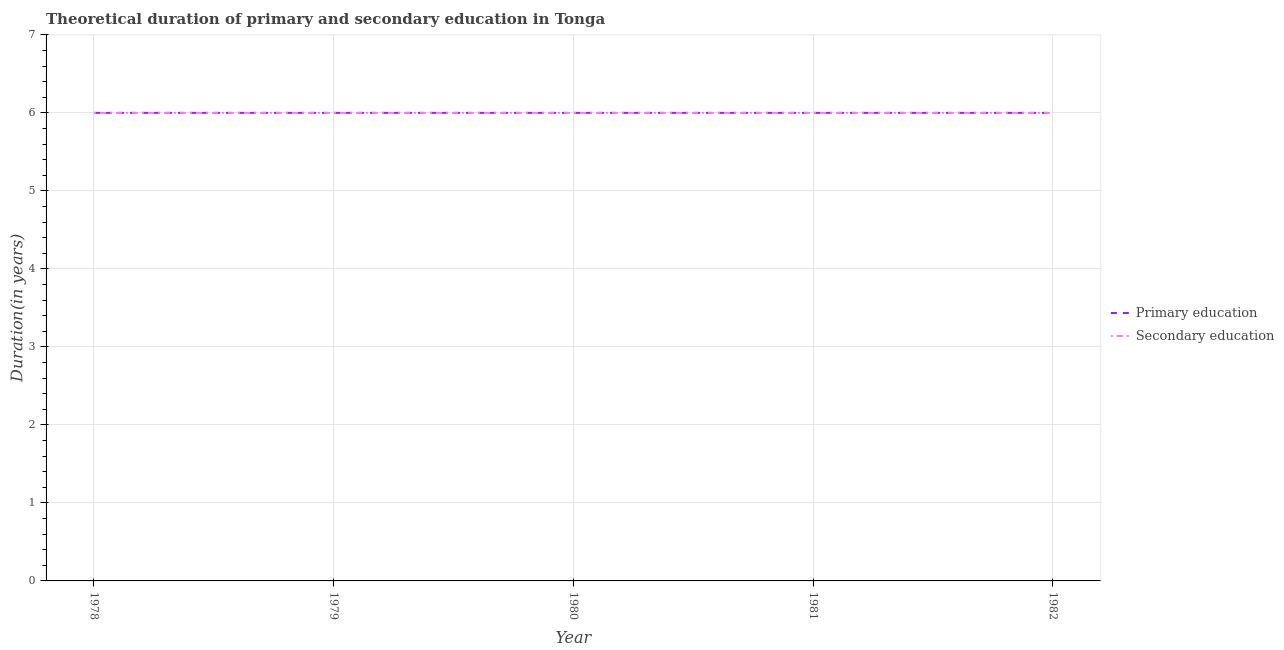Does the line corresponding to duration of primary education intersect with the line corresponding to duration of secondary education?
Offer a terse response. Yes. What is the duration of primary education in 1982?
Ensure brevity in your answer.  6. Across all years, what is the maximum duration of secondary education?
Make the answer very short. 6. In which year was the duration of secondary education maximum?
Provide a succinct answer. 1978. In which year was the duration of secondary education minimum?
Provide a short and direct response. 1978. What is the total duration of primary education in the graph?
Offer a very short reply. 30. What is the difference between the duration of primary education in 1981 and that in 1982?
Ensure brevity in your answer.  0. What is the difference between the duration of primary education in 1981 and the duration of secondary education in 1982?
Give a very brief answer. 0. In the year 1980, what is the difference between the duration of primary education and duration of secondary education?
Your response must be concise. 0. What is the ratio of the duration of primary education in 1979 to that in 1980?
Your answer should be very brief. 1. Is the difference between the duration of secondary education in 1980 and 1981 greater than the difference between the duration of primary education in 1980 and 1981?
Provide a succinct answer. No. Does the duration of secondary education monotonically increase over the years?
Provide a short and direct response. No. How many years are there in the graph?
Provide a succinct answer. 5. Are the values on the major ticks of Y-axis written in scientific E-notation?
Offer a very short reply. No. Does the graph contain grids?
Keep it short and to the point. Yes. How many legend labels are there?
Ensure brevity in your answer.  2. How are the legend labels stacked?
Provide a succinct answer. Vertical. What is the title of the graph?
Your response must be concise. Theoretical duration of primary and secondary education in Tonga. Does "Working capital" appear as one of the legend labels in the graph?
Ensure brevity in your answer.  No. What is the label or title of the Y-axis?
Offer a very short reply. Duration(in years). What is the Duration(in years) of Primary education in 1979?
Offer a terse response. 6. What is the Duration(in years) of Secondary education in 1980?
Give a very brief answer. 6. What is the Duration(in years) in Primary education in 1981?
Provide a short and direct response. 6. What is the Duration(in years) of Secondary education in 1982?
Keep it short and to the point. 6. Across all years, what is the minimum Duration(in years) in Primary education?
Your response must be concise. 6. Across all years, what is the minimum Duration(in years) of Secondary education?
Your answer should be very brief. 6. What is the total Duration(in years) of Secondary education in the graph?
Make the answer very short. 30. What is the difference between the Duration(in years) in Primary education in 1978 and that in 1979?
Give a very brief answer. 0. What is the difference between the Duration(in years) in Primary education in 1978 and that in 1980?
Offer a terse response. 0. What is the difference between the Duration(in years) of Primary education in 1978 and that in 1981?
Your response must be concise. 0. What is the difference between the Duration(in years) of Secondary education in 1978 and that in 1981?
Provide a succinct answer. 0. What is the difference between the Duration(in years) in Primary education in 1979 and that in 1982?
Your answer should be very brief. 0. What is the difference between the Duration(in years) in Secondary education in 1979 and that in 1982?
Give a very brief answer. 0. What is the difference between the Duration(in years) of Primary education in 1980 and that in 1981?
Give a very brief answer. 0. What is the difference between the Duration(in years) of Primary education in 1981 and that in 1982?
Keep it short and to the point. 0. What is the difference between the Duration(in years) of Primary education in 1978 and the Duration(in years) of Secondary education in 1981?
Provide a short and direct response. 0. What is the difference between the Duration(in years) of Primary education in 1979 and the Duration(in years) of Secondary education in 1980?
Ensure brevity in your answer.  0. What is the difference between the Duration(in years) in Primary education in 1980 and the Duration(in years) in Secondary education in 1981?
Provide a succinct answer. 0. What is the difference between the Duration(in years) of Primary education in 1980 and the Duration(in years) of Secondary education in 1982?
Ensure brevity in your answer.  0. What is the average Duration(in years) in Secondary education per year?
Offer a very short reply. 6. In the year 1978, what is the difference between the Duration(in years) in Primary education and Duration(in years) in Secondary education?
Give a very brief answer. 0. In the year 1979, what is the difference between the Duration(in years) of Primary education and Duration(in years) of Secondary education?
Your answer should be compact. 0. In the year 1980, what is the difference between the Duration(in years) of Primary education and Duration(in years) of Secondary education?
Give a very brief answer. 0. In the year 1982, what is the difference between the Duration(in years) in Primary education and Duration(in years) in Secondary education?
Your response must be concise. 0. What is the ratio of the Duration(in years) in Secondary education in 1978 to that in 1980?
Your response must be concise. 1. What is the ratio of the Duration(in years) in Primary education in 1978 to that in 1981?
Make the answer very short. 1. What is the ratio of the Duration(in years) in Secondary education in 1978 to that in 1981?
Your answer should be very brief. 1. What is the ratio of the Duration(in years) in Primary education in 1978 to that in 1982?
Provide a succinct answer. 1. What is the ratio of the Duration(in years) in Primary education in 1979 to that in 1980?
Offer a very short reply. 1. What is the ratio of the Duration(in years) in Secondary education in 1979 to that in 1980?
Keep it short and to the point. 1. What is the ratio of the Duration(in years) of Secondary education in 1979 to that in 1981?
Your answer should be very brief. 1. What is the ratio of the Duration(in years) of Secondary education in 1980 to that in 1981?
Make the answer very short. 1. What is the ratio of the Duration(in years) of Primary education in 1980 to that in 1982?
Your response must be concise. 1. What is the ratio of the Duration(in years) of Secondary education in 1980 to that in 1982?
Offer a very short reply. 1. What is the ratio of the Duration(in years) in Primary education in 1981 to that in 1982?
Provide a succinct answer. 1. What is the difference between the highest and the second highest Duration(in years) of Secondary education?
Offer a terse response. 0. What is the difference between the highest and the lowest Duration(in years) in Primary education?
Ensure brevity in your answer.  0. What is the difference between the highest and the lowest Duration(in years) in Secondary education?
Provide a succinct answer. 0. 